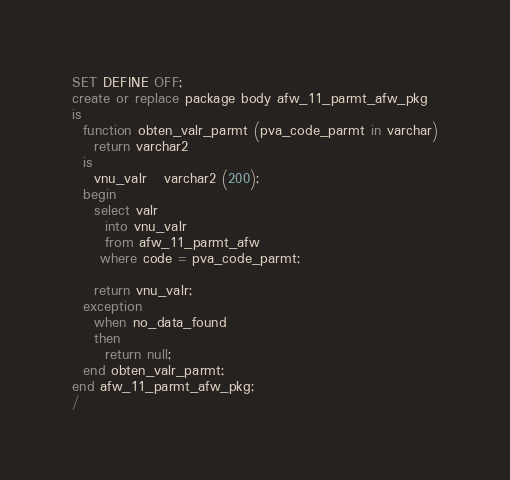Convert code to text. <code><loc_0><loc_0><loc_500><loc_500><_SQL_>SET DEFINE OFF;
create or replace package body afw_11_parmt_afw_pkg
is
  function obten_valr_parmt (pva_code_parmt in varchar)
    return varchar2
  is
    vnu_valr   varchar2 (200);
  begin
    select valr
      into vnu_valr
      from afw_11_parmt_afw
     where code = pva_code_parmt;

    return vnu_valr;
  exception
    when no_data_found
    then
      return null;
  end obten_valr_parmt;
end afw_11_parmt_afw_pkg;
/
</code> 